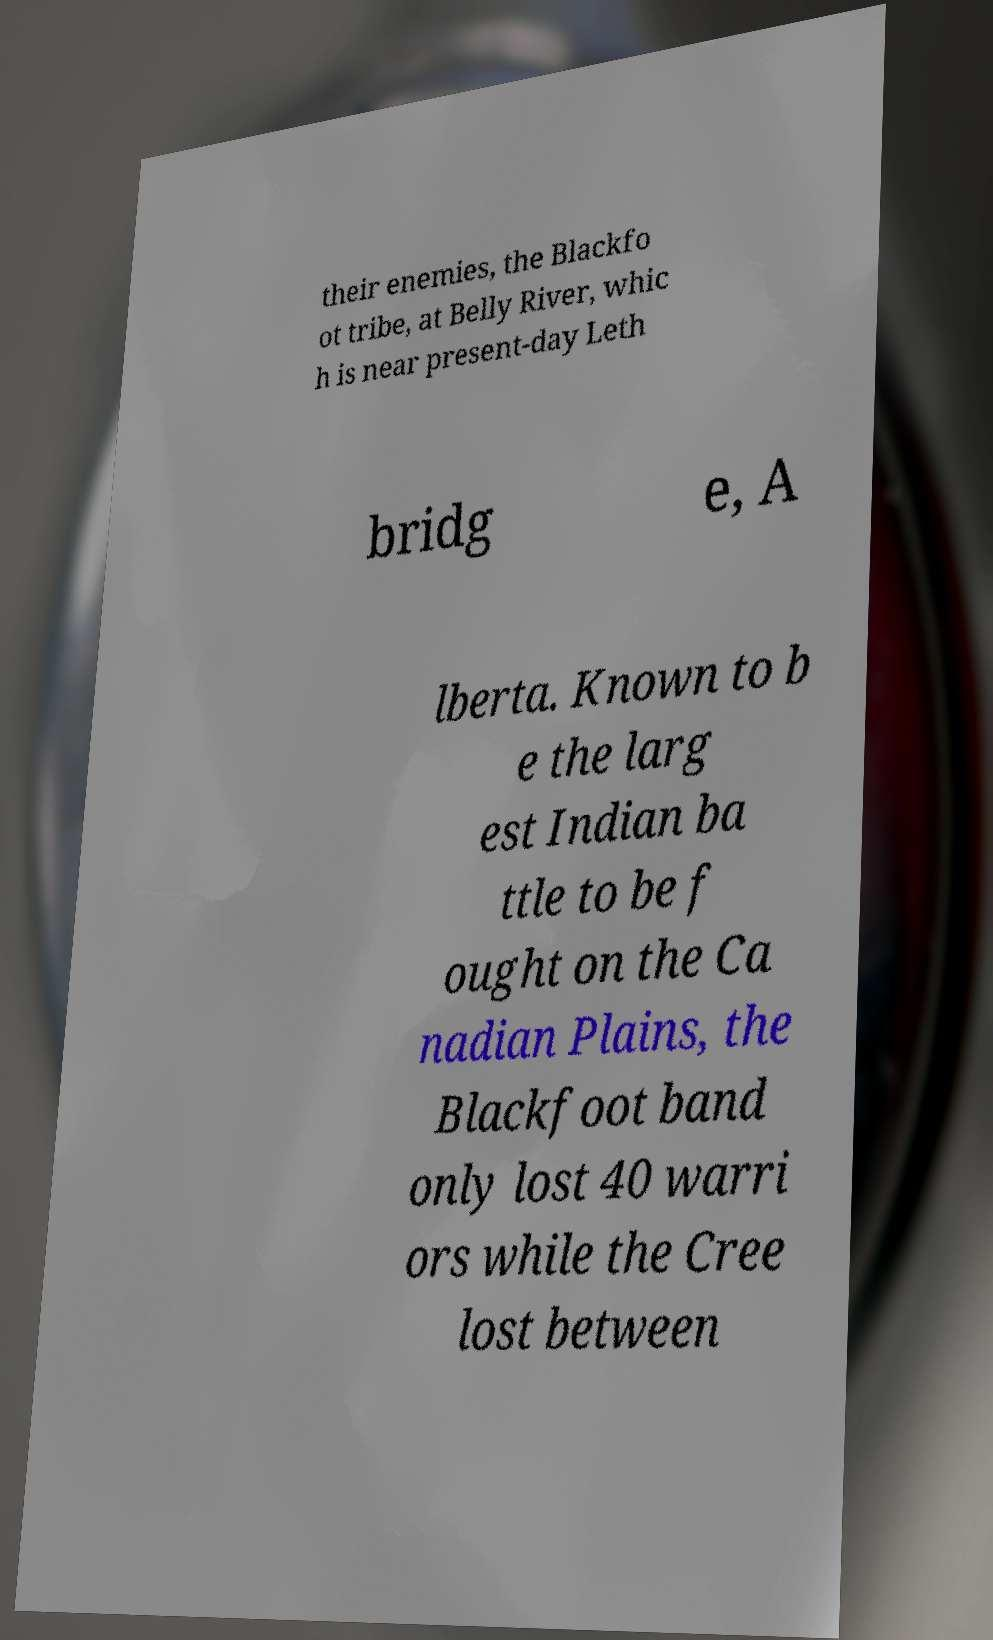Please identify and transcribe the text found in this image. their enemies, the Blackfo ot tribe, at Belly River, whic h is near present-day Leth bridg e, A lberta. Known to b e the larg est Indian ba ttle to be f ought on the Ca nadian Plains, the Blackfoot band only lost 40 warri ors while the Cree lost between 